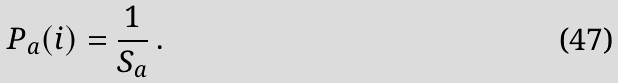<formula> <loc_0><loc_0><loc_500><loc_500>P _ { a } ( i ) = \frac { 1 } { S _ { a } } \, .</formula> 